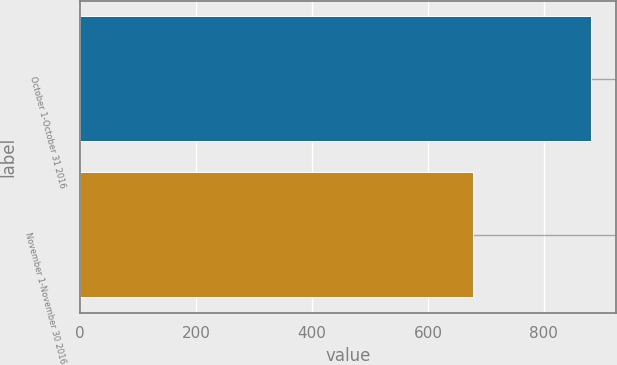<chart> <loc_0><loc_0><loc_500><loc_500><bar_chart><fcel>October 1-October 31 2016<fcel>November 1-November 30 2016<nl><fcel>881<fcel>677.1<nl></chart> 